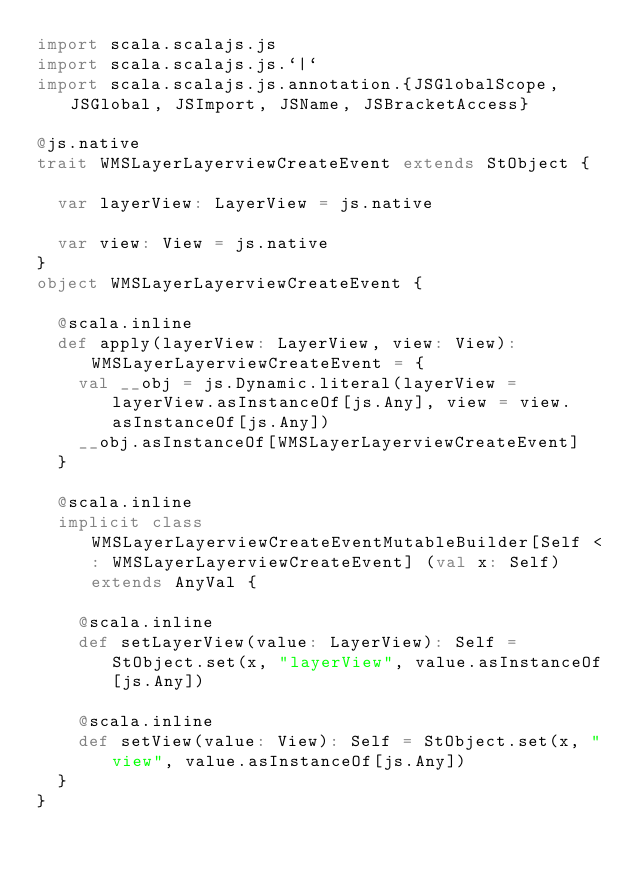Convert code to text. <code><loc_0><loc_0><loc_500><loc_500><_Scala_>import scala.scalajs.js
import scala.scalajs.js.`|`
import scala.scalajs.js.annotation.{JSGlobalScope, JSGlobal, JSImport, JSName, JSBracketAccess}

@js.native
trait WMSLayerLayerviewCreateEvent extends StObject {
  
  var layerView: LayerView = js.native
  
  var view: View = js.native
}
object WMSLayerLayerviewCreateEvent {
  
  @scala.inline
  def apply(layerView: LayerView, view: View): WMSLayerLayerviewCreateEvent = {
    val __obj = js.Dynamic.literal(layerView = layerView.asInstanceOf[js.Any], view = view.asInstanceOf[js.Any])
    __obj.asInstanceOf[WMSLayerLayerviewCreateEvent]
  }
  
  @scala.inline
  implicit class WMSLayerLayerviewCreateEventMutableBuilder[Self <: WMSLayerLayerviewCreateEvent] (val x: Self) extends AnyVal {
    
    @scala.inline
    def setLayerView(value: LayerView): Self = StObject.set(x, "layerView", value.asInstanceOf[js.Any])
    
    @scala.inline
    def setView(value: View): Self = StObject.set(x, "view", value.asInstanceOf[js.Any])
  }
}
</code> 